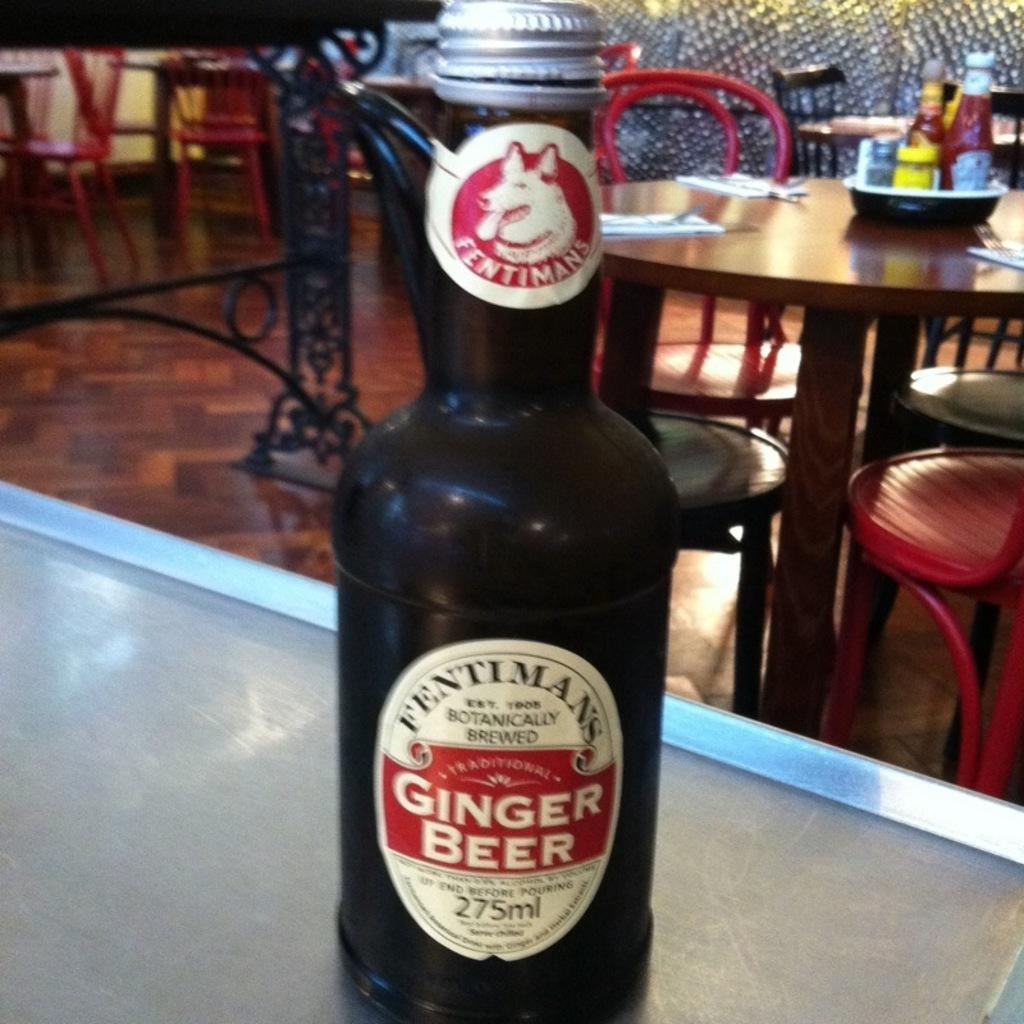What object is on the table in the image? There is a bottle on the table. What might be the purpose of the bottle? The purpose of the bottle could be to hold a liquid or other substance. Can you describe the table's appearance or any other objects on it? Unfortunately, the provided facts do not mention any other objects on the table or describe its appearance. What type of verse is written on the bottle in the image? There is no verse written on the bottle in the image. How many legs does the bottle have in the image? Bottles do not have legs; they are typically cylindrical objects with a base that allows them to stand upright. 